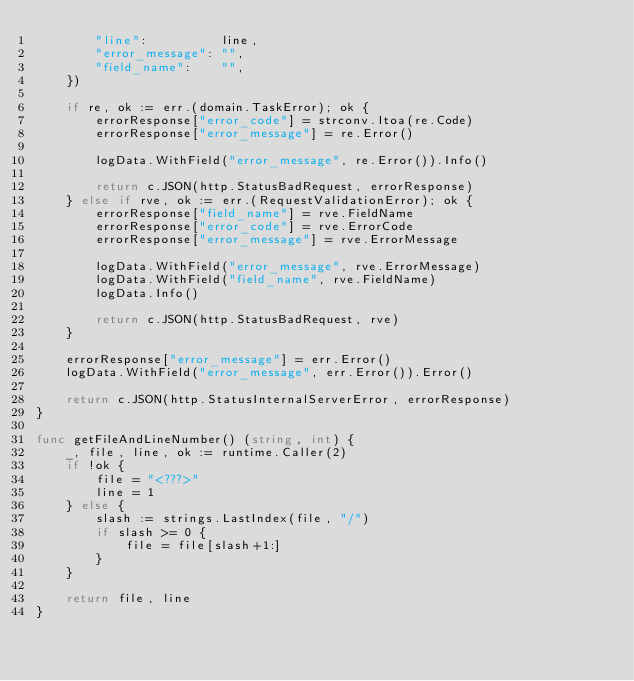Convert code to text. <code><loc_0><loc_0><loc_500><loc_500><_Go_>		"line":          line,
		"error_message": "",
		"field_name":    "",
	})

	if re, ok := err.(domain.TaskError); ok {
		errorResponse["error_code"] = strconv.Itoa(re.Code)
		errorResponse["error_message"] = re.Error()

		logData.WithField("error_message", re.Error()).Info()

		return c.JSON(http.StatusBadRequest, errorResponse)
	} else if rve, ok := err.(RequestValidationError); ok {
		errorResponse["field_name"] = rve.FieldName
		errorResponse["error_code"] = rve.ErrorCode
		errorResponse["error_message"] = rve.ErrorMessage

		logData.WithField("error_message", rve.ErrorMessage)
		logData.WithField("field_name", rve.FieldName)
		logData.Info()

		return c.JSON(http.StatusBadRequest, rve)
	}

	errorResponse["error_message"] = err.Error()
	logData.WithField("error_message", err.Error()).Error()

	return c.JSON(http.StatusInternalServerError, errorResponse)
}

func getFileAndLineNumber() (string, int) {
	_, file, line, ok := runtime.Caller(2)
	if !ok {
		file = "<???>"
		line = 1
	} else {
		slash := strings.LastIndex(file, "/")
		if slash >= 0 {
			file = file[slash+1:]
		}
	}

	return file, line
}
</code> 